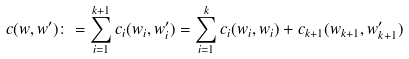<formula> <loc_0><loc_0><loc_500><loc_500>c ( w , w ^ { \prime } ) \colon = \sum _ { i = 1 } ^ { k + 1 } c _ { i } ( w _ { i } , w ^ { \prime } _ { i } ) = \sum _ { i = 1 } ^ { k } c _ { i } ( w _ { i } , w _ { i } ) + c _ { k + 1 } ( w _ { k + 1 } , w ^ { \prime } _ { k + 1 } )</formula> 